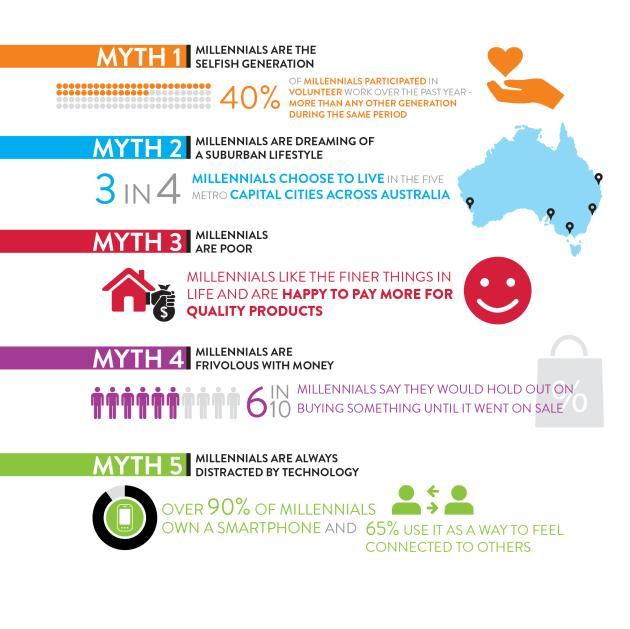Highlight a few significant elements in this photo. A significant number of millennials chose not to live in metropolitan capital cities. According to a recent study, it was found that approximately 60% of millennials have not participated in volunteer work. There are five myths listed in the infographic. A significant percentage of millennials do not own a smartphone. According to a recent survey, only 35% of millennials do not use their smartphones to connect with others. 